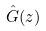Convert formula to latex. <formula><loc_0><loc_0><loc_500><loc_500>\hat { G } ( z )</formula> 